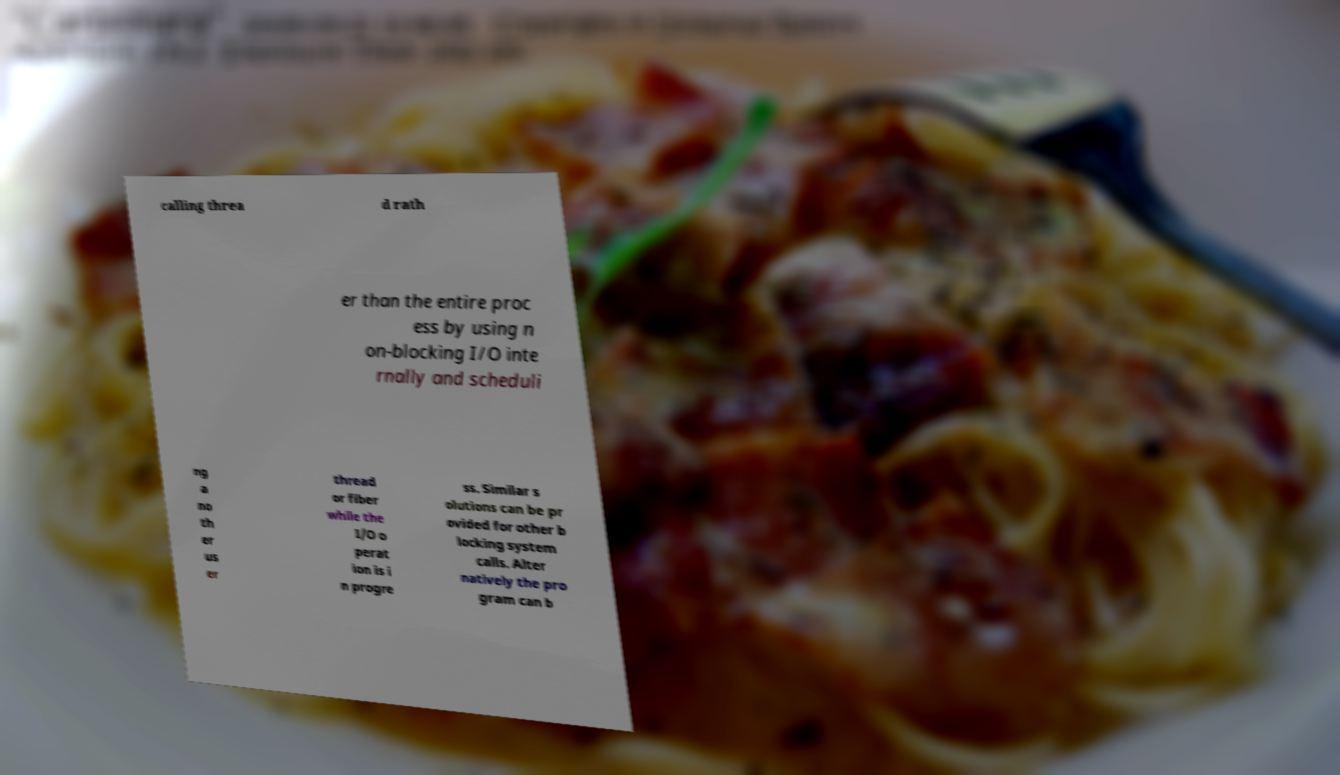Please identify and transcribe the text found in this image. calling threa d rath er than the entire proc ess by using n on-blocking I/O inte rnally and scheduli ng a no th er us er thread or fiber while the I/O o perat ion is i n progre ss. Similar s olutions can be pr ovided for other b locking system calls. Alter natively the pro gram can b 